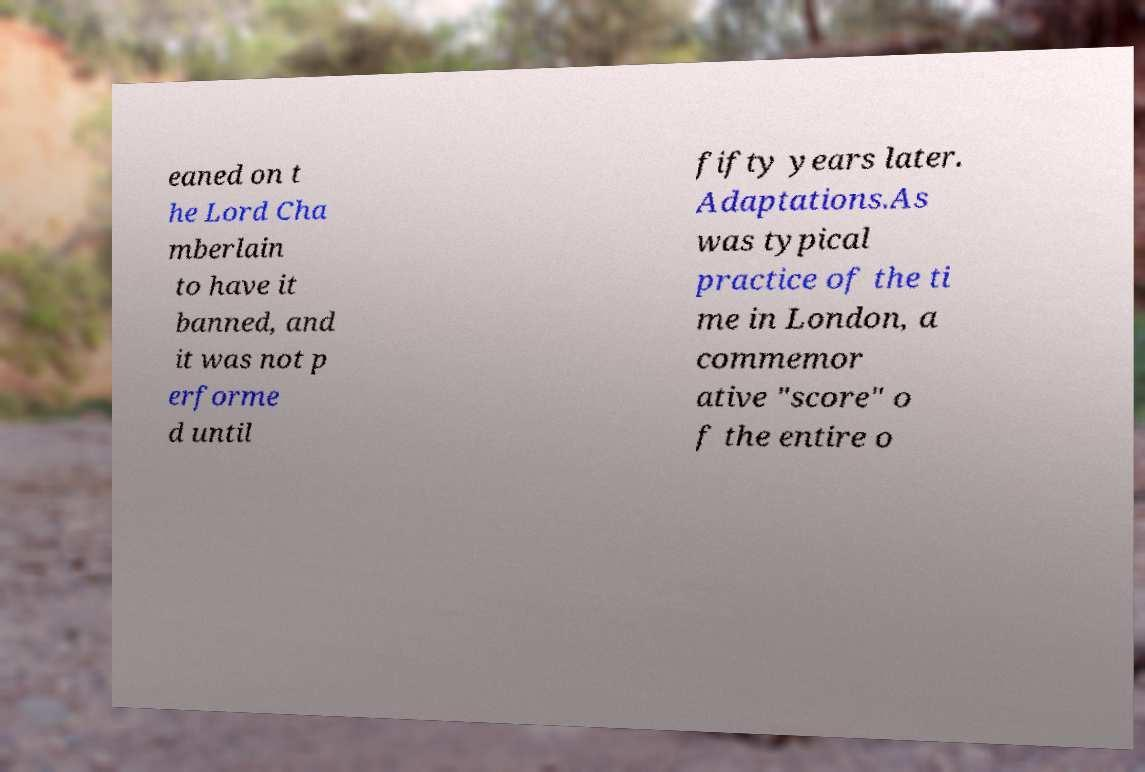Please read and relay the text visible in this image. What does it say? eaned on t he Lord Cha mberlain to have it banned, and it was not p erforme d until fifty years later. Adaptations.As was typical practice of the ti me in London, a commemor ative "score" o f the entire o 